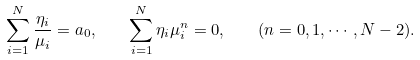Convert formula to latex. <formula><loc_0><loc_0><loc_500><loc_500>\sum _ { i = 1 } ^ { N } \frac { \eta _ { i } } { \mu _ { i } } = a _ { 0 } , \quad \sum _ { i = 1 } ^ { N } \eta _ { i } \mu _ { i } ^ { n } = 0 , \quad ( n = 0 , 1 , \cdots , N - 2 ) .</formula> 